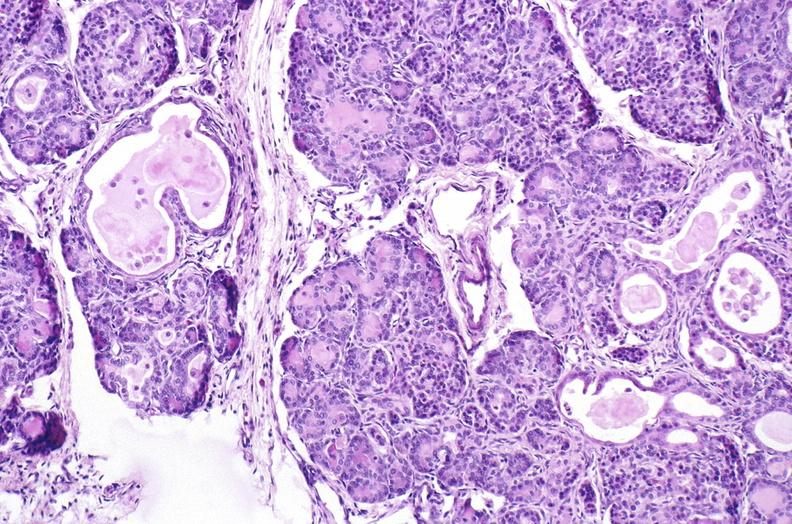s gangrene fingers present?
Answer the question using a single word or phrase. No 